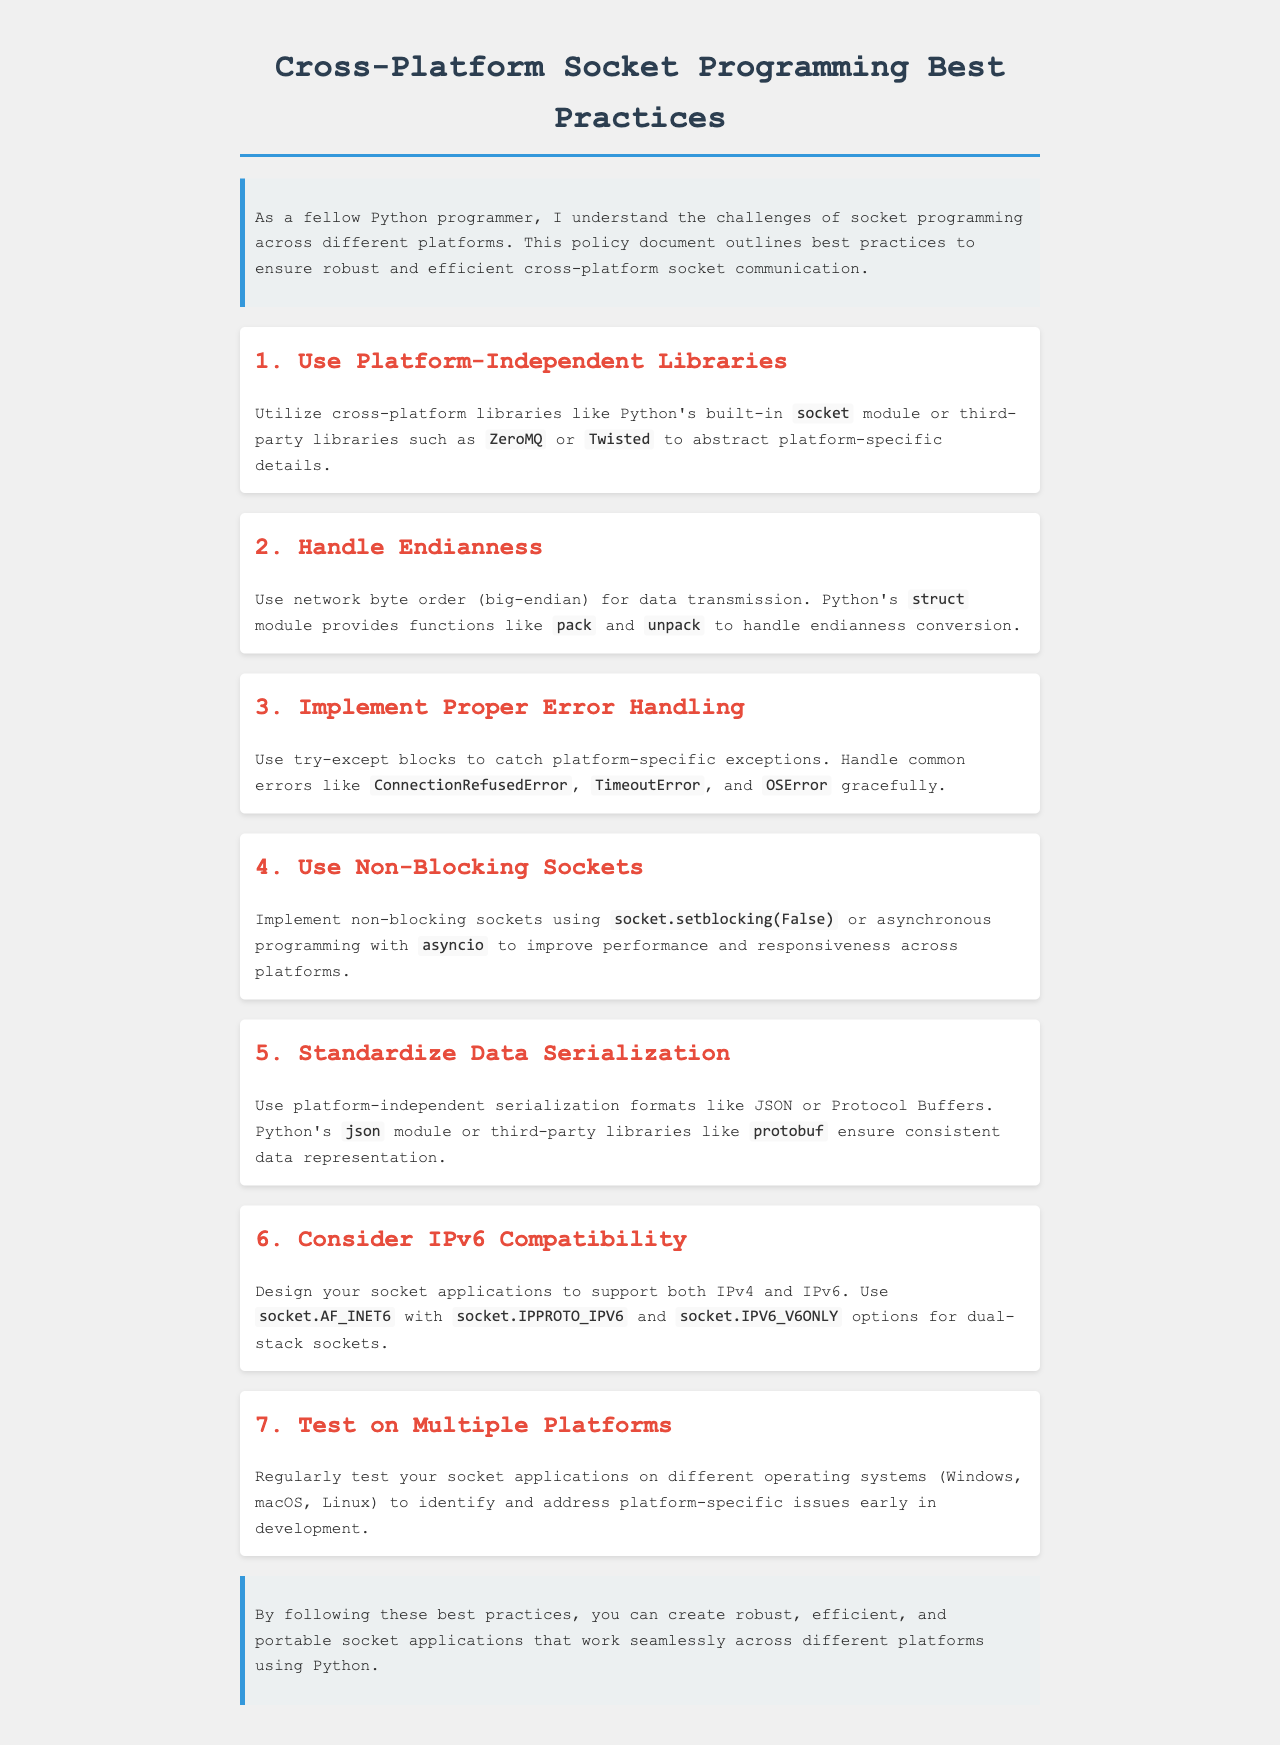What is the title of the document? The title is the main heading of the document provided in the HTML code.
Answer: Cross-Platform Socket Programming Best Practices What is the first best practice mentioned? The first best practice is the first item listed under the best practices section of the document.
Answer: Use Platform-Independent Libraries Which Python module is recommended for data serialization? The document mentions a specific Python module for serialization under the data serialization section.
Answer: json How many best practices are outlined in the document? The number of best practices can be counted from the sections listed in the document.
Answer: Seven What kind of sockets should be implemented for better performance? The recommendation for improving performance is found in the relevant section discussing socket types.
Answer: Non-Blocking Sockets What byte order should be used for data transmission? The document highlights the correct byte order for data transmission in the section about endianness.
Answer: Network byte order (big-endian) What does the section on testing recommend? The section discusses the importance of testing on different platforms, which is a single concept in the document.
Answer: Test on Multiple Platforms What programming model can enhance responsiveness? The document suggests a specific programming model that can enhance application responsiveness across platforms.
Answer: Asynchronous programming 